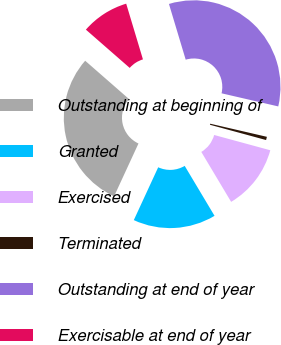Convert chart to OTSL. <chart><loc_0><loc_0><loc_500><loc_500><pie_chart><fcel>Outstanding at beginning of<fcel>Granted<fcel>Exercised<fcel>Terminated<fcel>Outstanding at end of year<fcel>Exercisable at end of year<nl><fcel>29.54%<fcel>15.46%<fcel>12.2%<fcel>0.61%<fcel>33.27%<fcel>8.93%<nl></chart> 